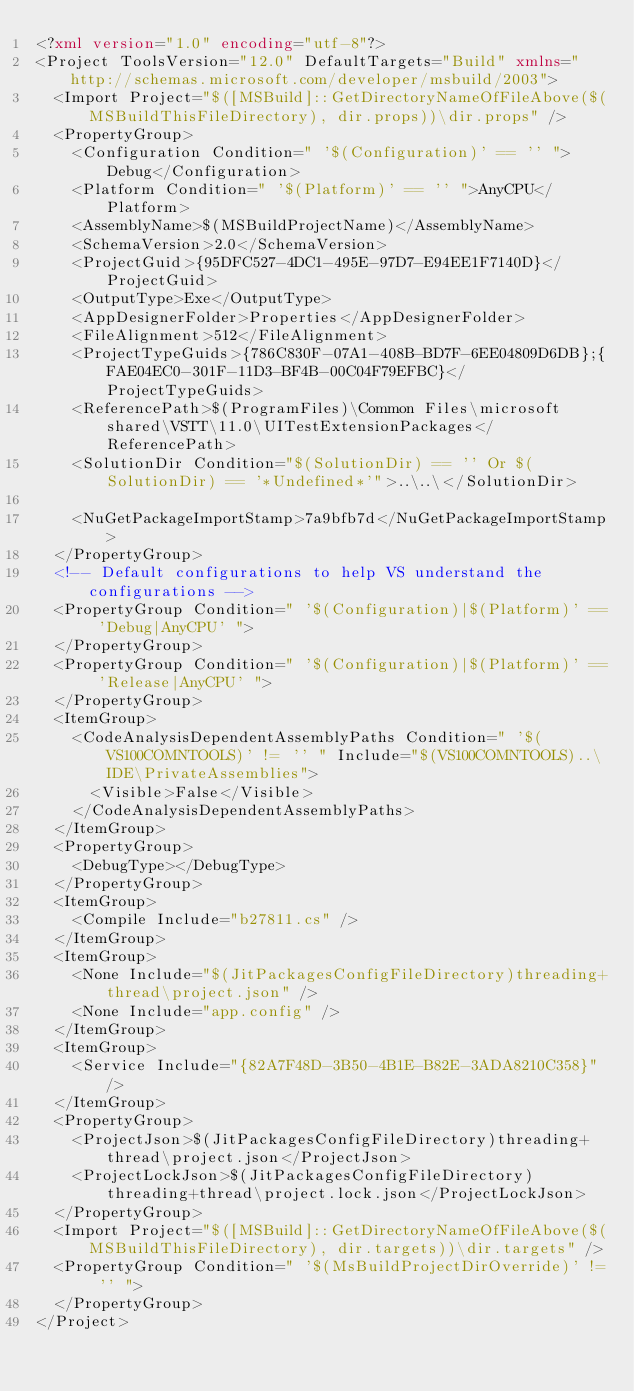Convert code to text. <code><loc_0><loc_0><loc_500><loc_500><_XML_><?xml version="1.0" encoding="utf-8"?>
<Project ToolsVersion="12.0" DefaultTargets="Build" xmlns="http://schemas.microsoft.com/developer/msbuild/2003">
  <Import Project="$([MSBuild]::GetDirectoryNameOfFileAbove($(MSBuildThisFileDirectory), dir.props))\dir.props" />
  <PropertyGroup>
    <Configuration Condition=" '$(Configuration)' == '' ">Debug</Configuration>
    <Platform Condition=" '$(Platform)' == '' ">AnyCPU</Platform>
    <AssemblyName>$(MSBuildProjectName)</AssemblyName>
    <SchemaVersion>2.0</SchemaVersion>
    <ProjectGuid>{95DFC527-4DC1-495E-97D7-E94EE1F7140D}</ProjectGuid>
    <OutputType>Exe</OutputType>
    <AppDesignerFolder>Properties</AppDesignerFolder>
    <FileAlignment>512</FileAlignment>
    <ProjectTypeGuids>{786C830F-07A1-408B-BD7F-6EE04809D6DB};{FAE04EC0-301F-11D3-BF4B-00C04F79EFBC}</ProjectTypeGuids>
    <ReferencePath>$(ProgramFiles)\Common Files\microsoft shared\VSTT\11.0\UITestExtensionPackages</ReferencePath>
    <SolutionDir Condition="$(SolutionDir) == '' Or $(SolutionDir) == '*Undefined*'">..\..\</SolutionDir>

    <NuGetPackageImportStamp>7a9bfb7d</NuGetPackageImportStamp>
  </PropertyGroup>
  <!-- Default configurations to help VS understand the configurations -->
  <PropertyGroup Condition=" '$(Configuration)|$(Platform)' == 'Debug|AnyCPU' ">
  </PropertyGroup>
  <PropertyGroup Condition=" '$(Configuration)|$(Platform)' == 'Release|AnyCPU' ">
  </PropertyGroup>
  <ItemGroup>
    <CodeAnalysisDependentAssemblyPaths Condition=" '$(VS100COMNTOOLS)' != '' " Include="$(VS100COMNTOOLS)..\IDE\PrivateAssemblies">
      <Visible>False</Visible>
    </CodeAnalysisDependentAssemblyPaths>
  </ItemGroup>
  <PropertyGroup>
    <DebugType></DebugType>
  </PropertyGroup>
  <ItemGroup>
    <Compile Include="b27811.cs" />
  </ItemGroup>
  <ItemGroup>
    <None Include="$(JitPackagesConfigFileDirectory)threading+thread\project.json" />
    <None Include="app.config" />
  </ItemGroup>
  <ItemGroup>
    <Service Include="{82A7F48D-3B50-4B1E-B82E-3ADA8210C358}" />
  </ItemGroup>
  <PropertyGroup>
    <ProjectJson>$(JitPackagesConfigFileDirectory)threading+thread\project.json</ProjectJson>
    <ProjectLockJson>$(JitPackagesConfigFileDirectory)threading+thread\project.lock.json</ProjectLockJson>
  </PropertyGroup>
  <Import Project="$([MSBuild]::GetDirectoryNameOfFileAbove($(MSBuildThisFileDirectory), dir.targets))\dir.targets" />
  <PropertyGroup Condition=" '$(MsBuildProjectDirOverride)' != '' ">
  </PropertyGroup> 
</Project>
</code> 